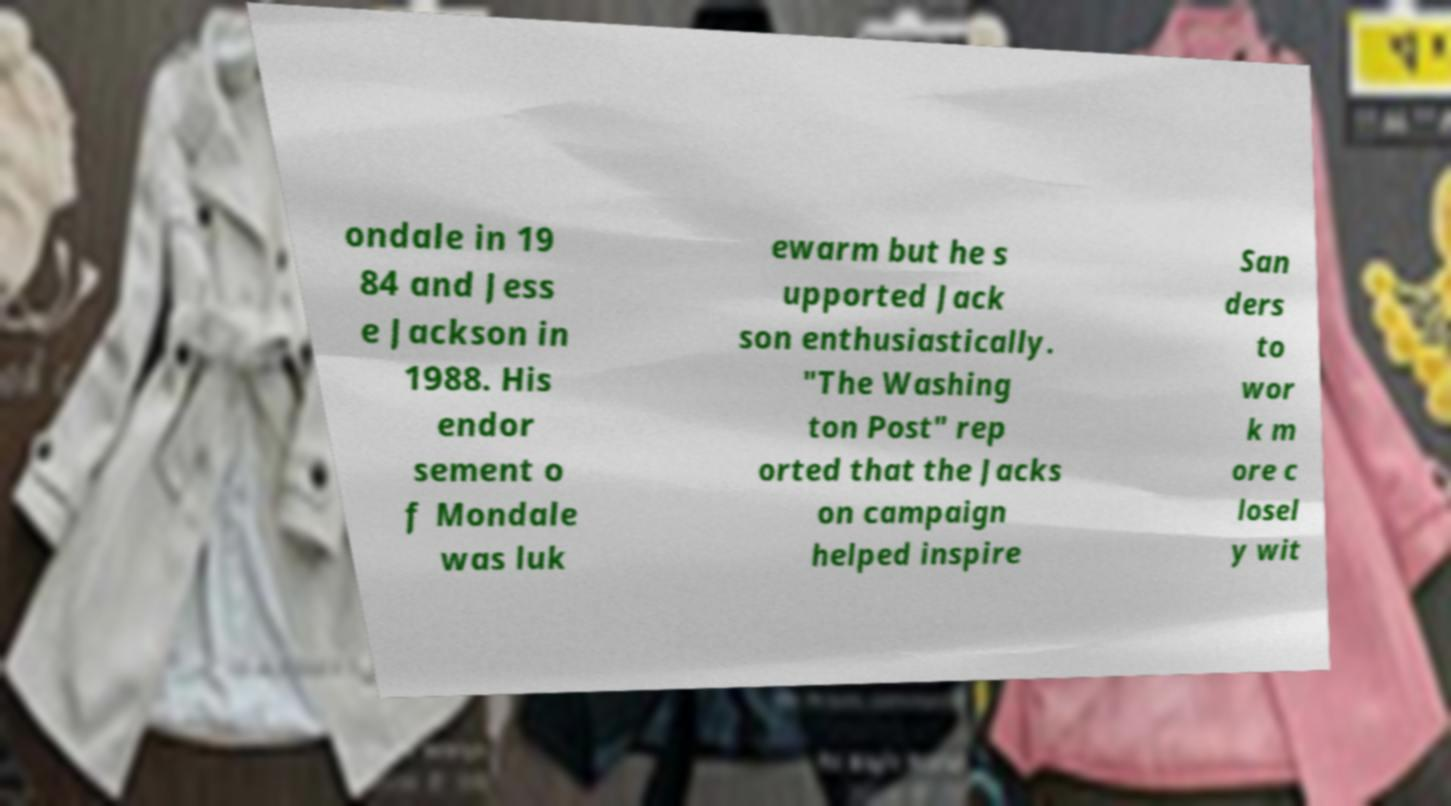Can you accurately transcribe the text from the provided image for me? ondale in 19 84 and Jess e Jackson in 1988. His endor sement o f Mondale was luk ewarm but he s upported Jack son enthusiastically. "The Washing ton Post" rep orted that the Jacks on campaign helped inspire San ders to wor k m ore c losel y wit 